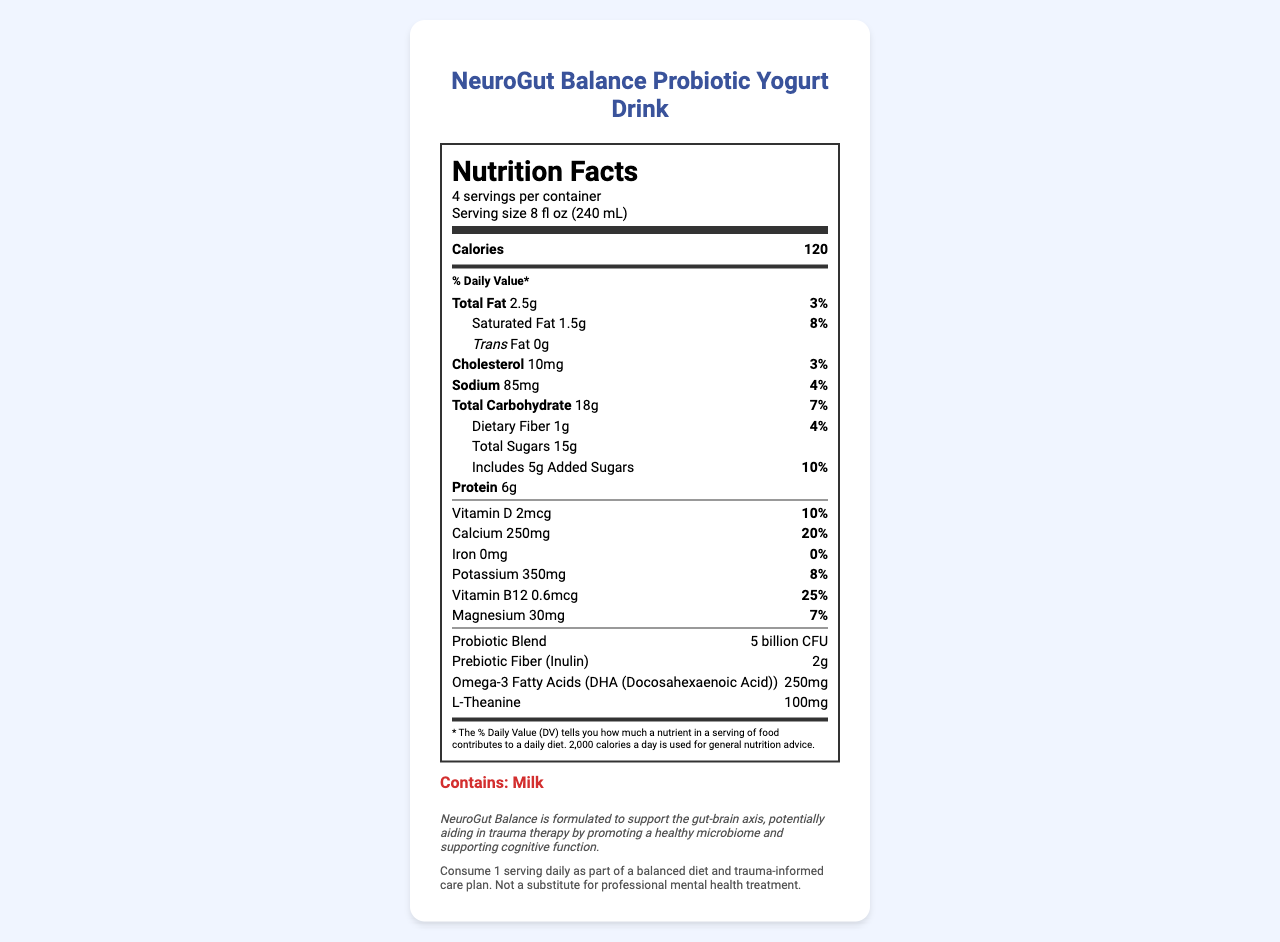what is the serving size? The serving size is clearly mentioned in the "serving info" section.
Answer: 8 fl oz (240 mL) how many servings are there per container? The number of servings per container is detailed in the "serving info" section.
Answer: 4 what is the calorie count per serving? The calories per serving are displayed in the bold "Calories" section within the nutrition label.
Answer: 120 how much total fat is in a serving? The total fat content per serving is listed under "Total Fat" in the nutrition items.
Answer: 2.5g what percentage of the Daily Value is the Vitamin B12 content? The daily Value for Vitamin B12 is shown in the nutrition item under "Vitamin B12".
Answer: 25% how much L-Theanine is in a serving? The amount of L-Theanine is specified in the nutrition items.
Answer: 100mg how much added sugars are included in one serving? The amount of added sugars is noted under the Total Sugars section in the nutrition items.
Answer: 5g which probiotics are included in the blend? A. Lactobacillus rhamnosus GG B. Bifidobacterium longum C. Lactobacillus acidophilus D. All of the above All the mentioned probiotic strains are listed under the probiotic blend section.
Answer: D. All of the above what is the source of the prebiotic fiber in this drink? A. Fructooligosaccharides (FOS) B. Inulin C. Beta-glucan The source of prebiotic fiber is indicated as "Inulin" within the nutrition items.
Answer: B. Inulin does this product contain any allergens? It is stated under "allergen info" that the product contains milk.
Answer: Yes what is the recommended use for this product? The recommended use is provided in the section labeled "recommended use."
Answer: Consume 1 serving daily as part of a balanced diet and trauma-informed care plan. Not a substitute for professional mental health treatment. what minerals are included in the document? The minerals listed in the Nutrition Facts are Calcium, Iron, Potassium, and Magnesium.
Answer: Calcium, Iron, Potassium, Magnesium which ingredient is not listed? A. Natural flavors B. Artificial colors C. Pectin Artificial colors are not listed in the ingredients, while Natural flavors and Pectin are.
Answer: B. Artificial colors is there omega-3 fatty acid content mentioned? Omega-3 fatty acids content is specified (250mg DHA) in the nutrition items.
Answer: Yes is the total carbohydrate content higher than protein content per serving? The total carbohydrate content is 18g, whereas the protein content is 6g.
Answer: Yes summarize the main purpose of this product. The document describes the product's name, nutritional facts, ingredients, probiotic and prebiotic content, and its potential benefits for trauma therapy, emphasizing its support for gut-brain health.
Answer: NeuroGut Balance Probiotic Yogurt Drink is formulated to support gut-brain axis health, which may aid in trauma therapy through promoting a healthy microbiome and supporting cognitive function. how does the product support cognitive function? The document mentions that the product supports cognitive function but does not provide details on the specific mechanisms or ingredients responsible for this benefit.
Answer: Cannot be determined 